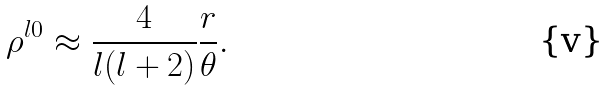Convert formula to latex. <formula><loc_0><loc_0><loc_500><loc_500>\rho ^ { l 0 } \approx \frac { 4 } { l ( l + 2 ) } \frac { r } { \theta } .</formula> 